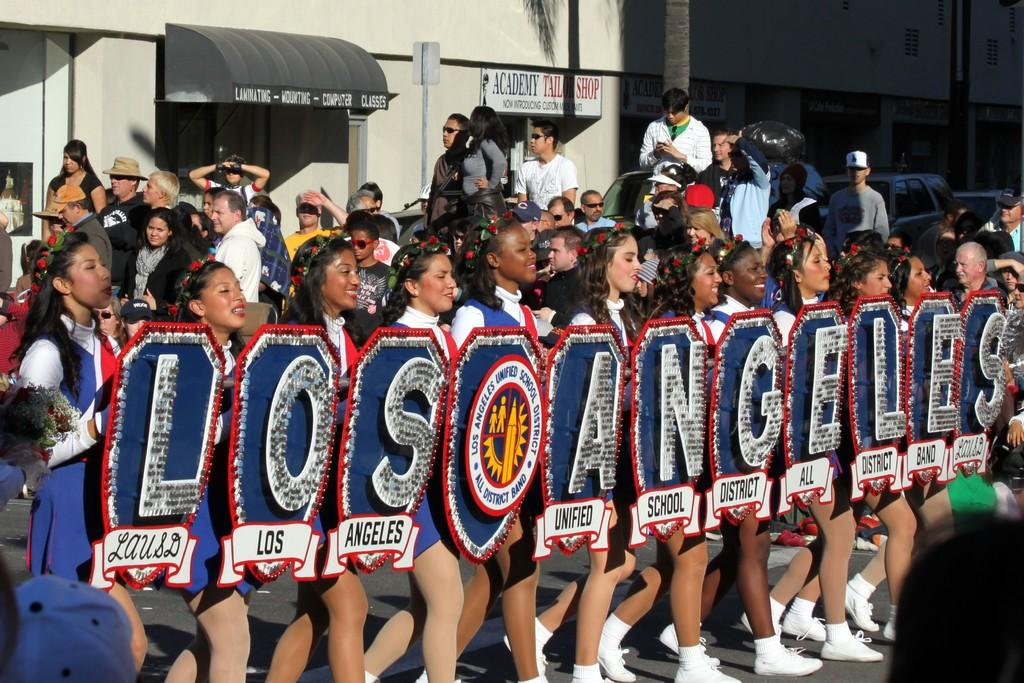<image>
Share a concise interpretation of the image provided. Women in a parade hold up signs that spell out Los Angeles. 